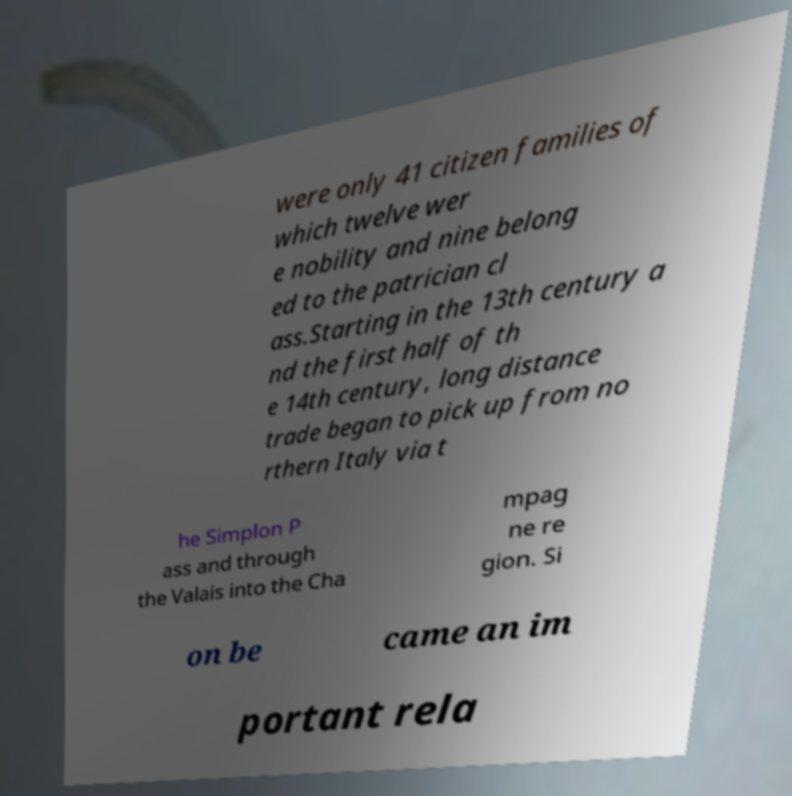Can you read and provide the text displayed in the image?This photo seems to have some interesting text. Can you extract and type it out for me? were only 41 citizen families of which twelve wer e nobility and nine belong ed to the patrician cl ass.Starting in the 13th century a nd the first half of th e 14th century, long distance trade began to pick up from no rthern Italy via t he Simplon P ass and through the Valais into the Cha mpag ne re gion. Si on be came an im portant rela 